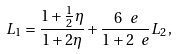Convert formula to latex. <formula><loc_0><loc_0><loc_500><loc_500>L _ { 1 } = \frac { 1 + \frac { 1 } { 2 } \eta } { 1 + 2 \eta } + \frac { 6 \ e } { 1 + 2 \ e } L _ { 2 } ,</formula> 